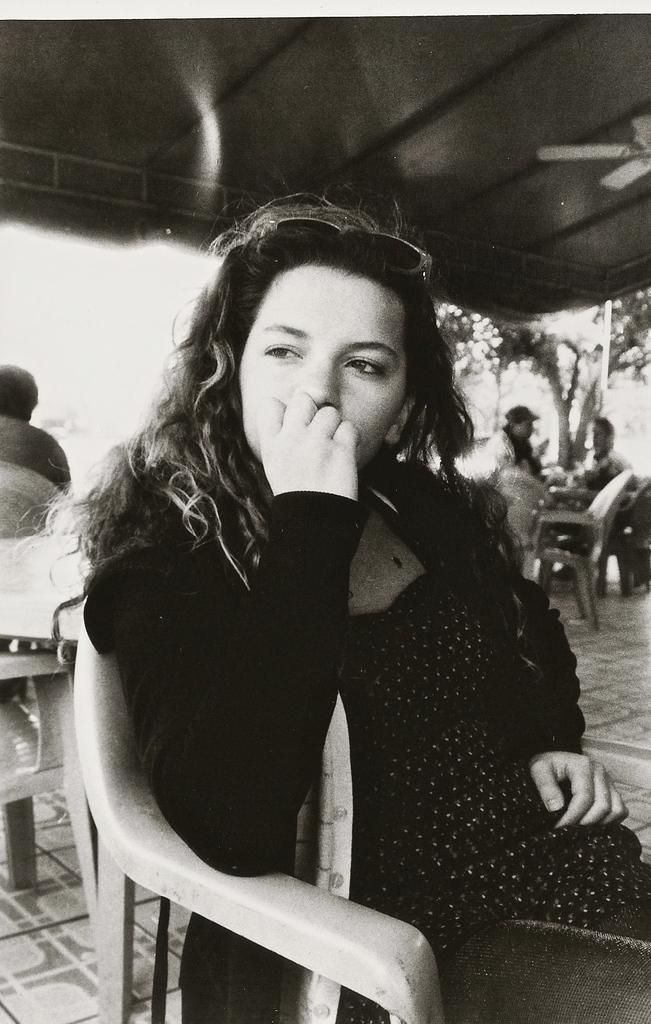Can you describe this image briefly? This pictures seems be of inside. In the foreground there is a woman sitting on the chair and in the background there are two persons sitting on the chair and we can see the tree, ceiling fan and another chair. 